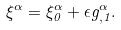Convert formula to latex. <formula><loc_0><loc_0><loc_500><loc_500>\xi ^ { \alpha } = \xi ^ { \alpha } _ { 0 } + \epsilon g ^ { \alpha } _ { , 1 } .</formula> 